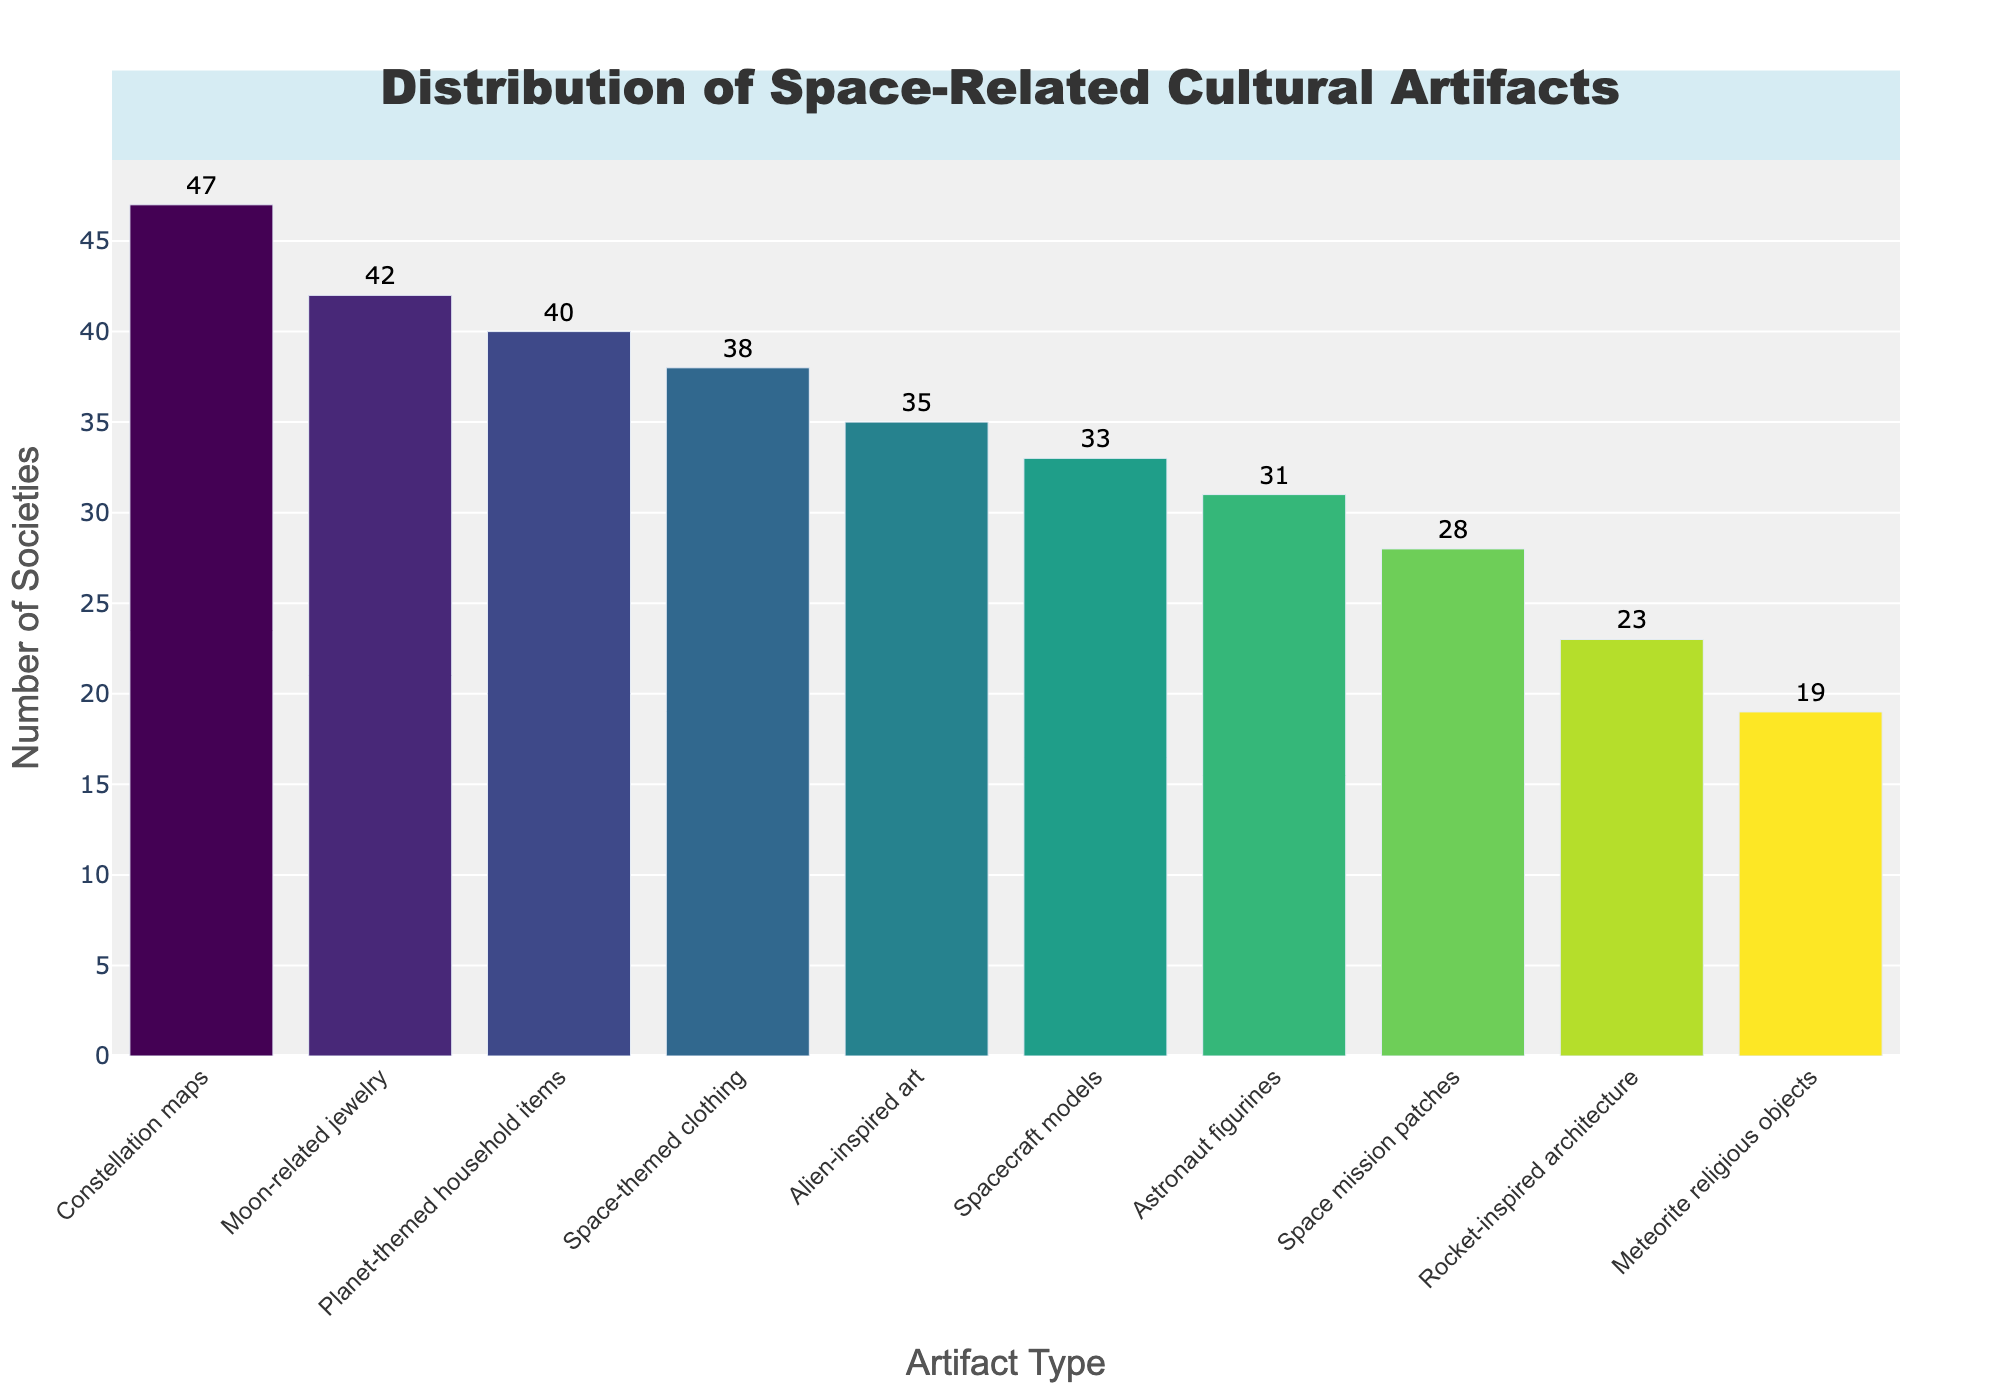What is the title of the histogram? The title, typically positioned at the top center of the plot, is "Distribution of Space-Related Cultural Artifacts".
Answer: "Distribution of Space-Related Cultural Artifacts" Which artifact type is found in the most societies? The artifact type with the highest bar in the histogram indicates the most common artifact. By looking at the highest bar, "Constellation maps" are identified with a count of 47.
Answer: "Constellation maps" How many societies have space mission patches? By examining the bar labeled "Space mission patches", we can see that this artifact type is found in 28 societies as indicated by the bar height and the number above it.
Answer: 28 Which artifact types have a count higher than 40? Checking each bar, those labeled "Moon-related jewelry", "Constellation maps", and "Planet-themed household items" have counts of 42, 47, and 40, respectively (the threshold being 40).
Answer: "Moon-related jewelry", "Constellation maps", "Planet-themed household items" What is the sum of societies that have space-related jewelry and space-themed clothing? Adding up the counts for "Moon-related jewelry" (42) and "Space-themed clothing" (38), we get 42 + 38.
Answer: 80 Which has more societies: rocket-inspired architecture or astronaut figurines? Comparing the bars for "Rocket-inspired architecture" (23) and "Astronaut figurines" (31), "Astronaut figurines" has a higher count.
Answer: "Astronaut figurines" What is the difference in the number of societies between alien-inspired art and meteorite religious objects? Subtracting the count of "Meteorite religious objects" (19) from "Alien-inspired art" (35), the difference is 35 - 19.
Answer: 16 How many artifact types have a count less than 30? Examining the bars, the types with counts below 30 are "Rocket-inspired architecture" (23) and "Meteorite religious objects" (19). Counting these gives us two artifact types.
Answer: 2 Which artifact type has a slightly higher count: spacecraft models or astronaut figurines? Comparing "Spacecraft models" (33) and "Astronaut figurines" (31), "Spacecraft models" has a slightly higher count.
Answer: "Spacecraft models" What is the average number of societies for the top three artifact types? The top three types are "Constellation maps" (47), "Moon-related jewelry" (42), and "Planet-themed household items" (40). Their average is (47 + 42 + 40) / 3.
Answer: 43 